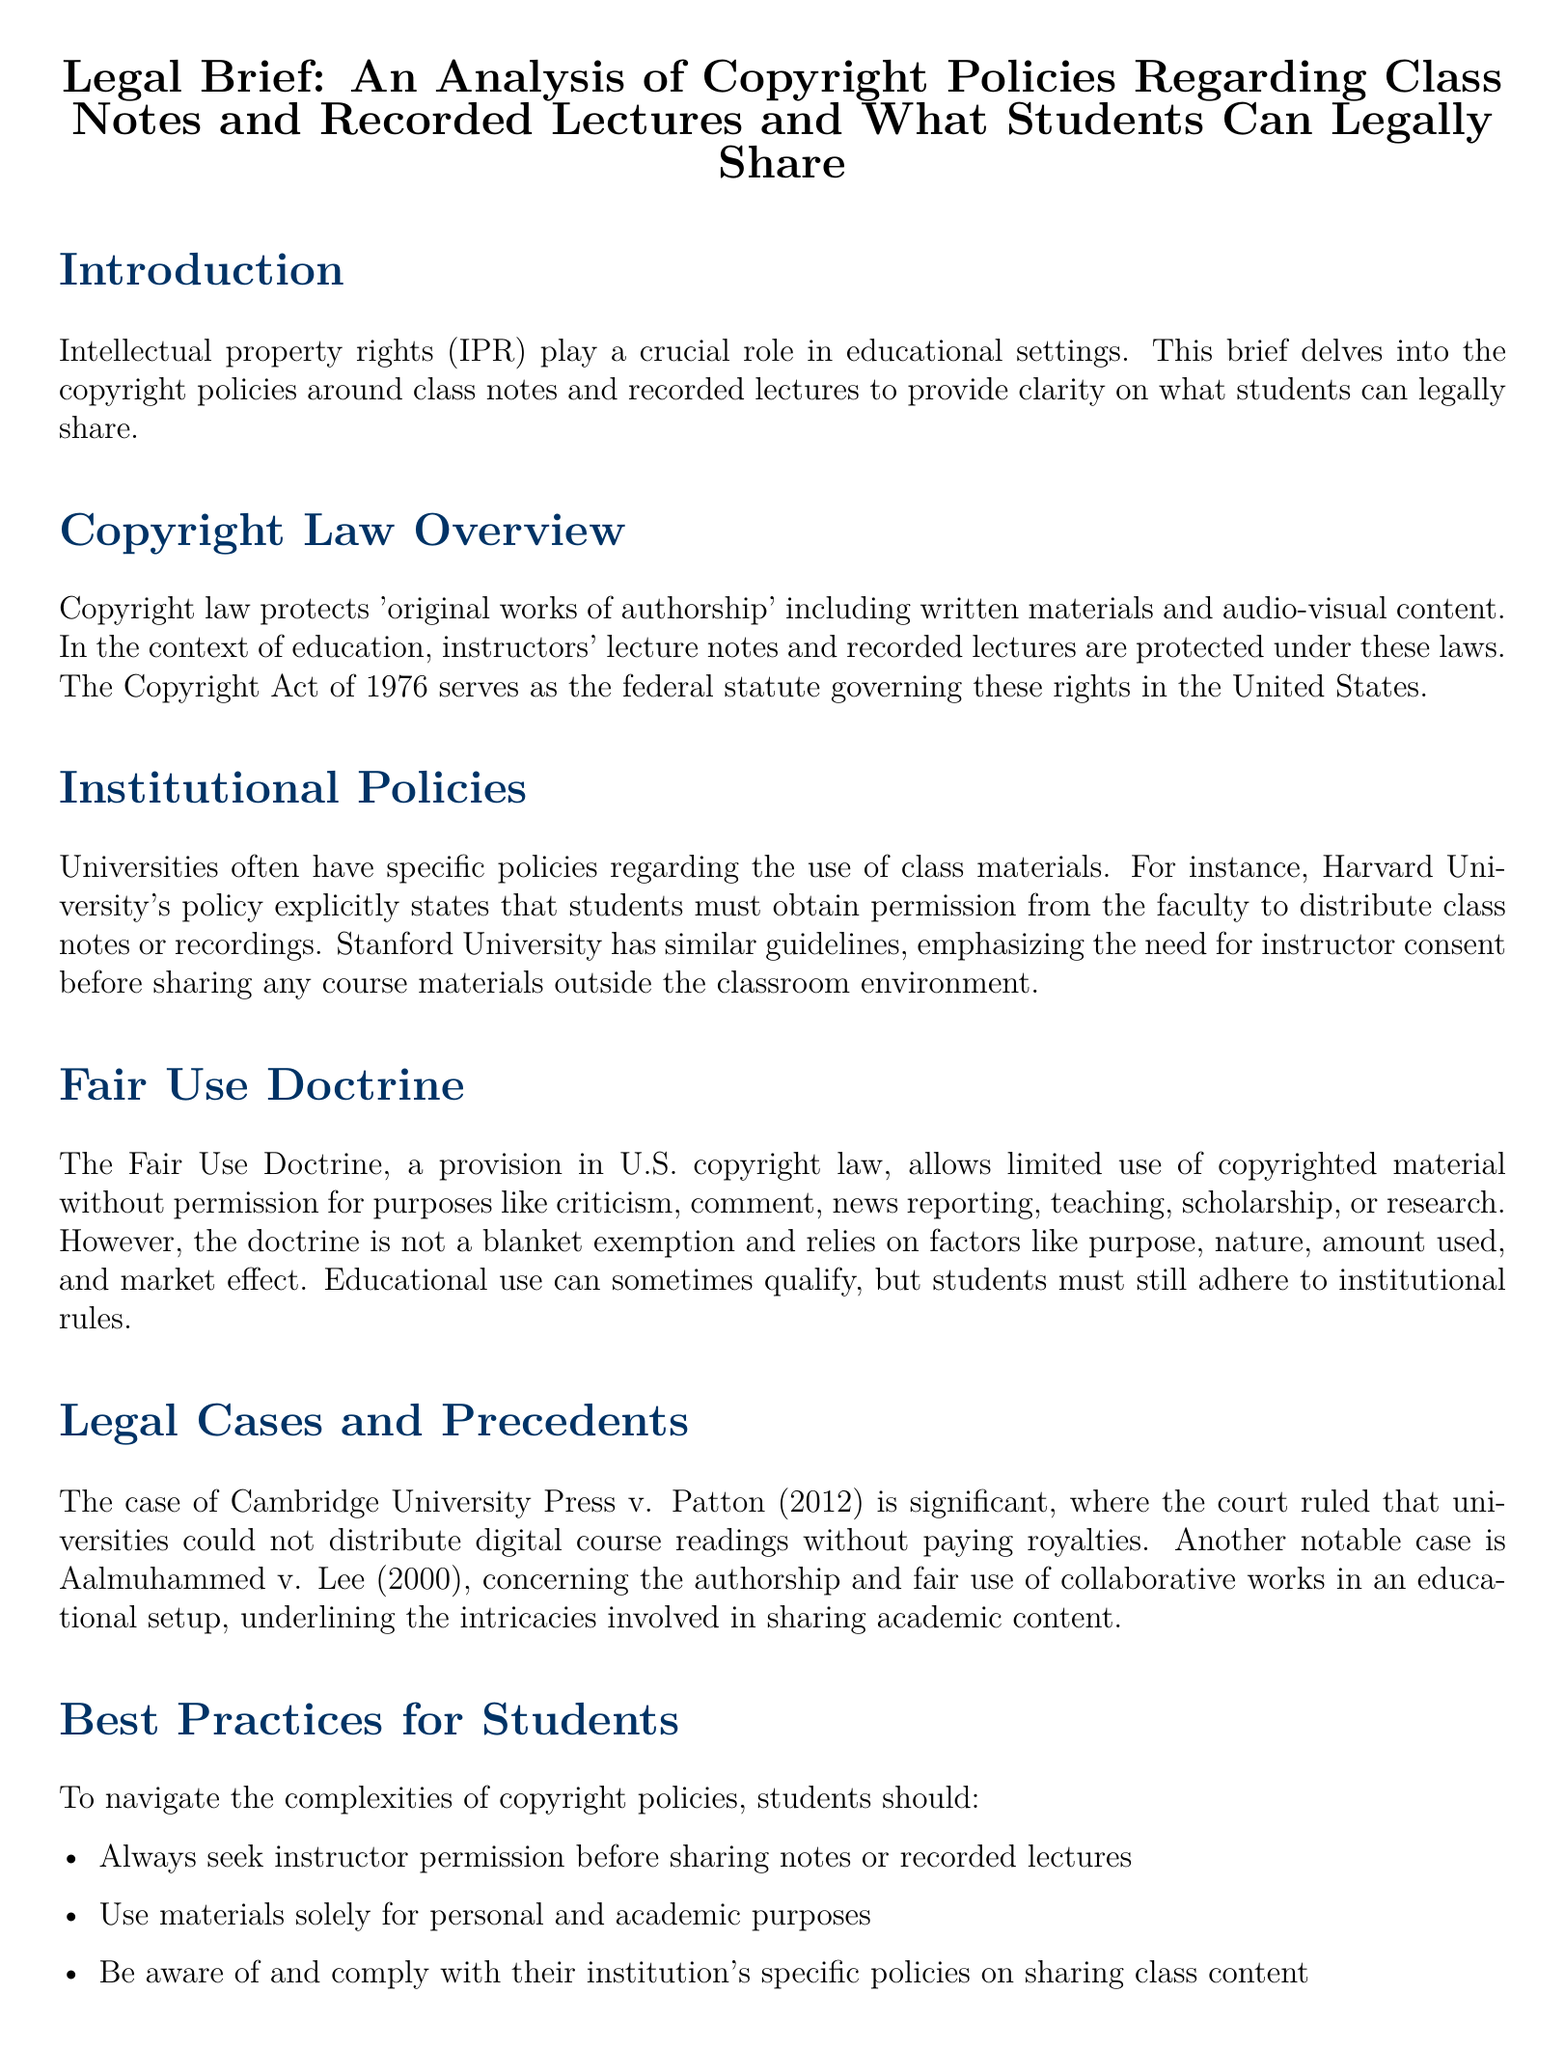What is the title of the document? The title is presented prominently at the top of the document.
Answer: Legal Brief: An Analysis of Copyright Policies Regarding Class Notes and Recorded Lectures and What Students Can Legally Share What year is cited as the governing statute for copyright law? The document mentions this specific year in the context of federal law governing copyright.
Answer: 1976 Which university's policy states that students must obtain permission to distribute class notes? This information is available in the section discussing institutional policies.
Answer: Harvard University What doctrine allows limited use of copyrighted material? The document outlines this principle under copyright law.
Answer: Fair Use Doctrine What case is mentioned as significant concerning digital course readings? This case emphasizes the legal implications of distributing educational materials.
Answer: Cambridge University Press v. Patton What is a recommended best practice for students when sharing class materials? The document lists multiple best practices, one of which is vital.
Answer: Seek instructor permission How many factors does the Fair Use Doctrine rely on? The specific number of factors related to fair use is indicated in the document.
Answer: Four Which legal case concerns authorship and fair use in educational settings? It is discussed as another notable example in the legal cases section.
Answer: Aalmuhammed v. Lee What type of use sometimes qualifies under the Fair Use Doctrine? The context of educational use is specifically highlighted in the document.
Answer: Educational use 